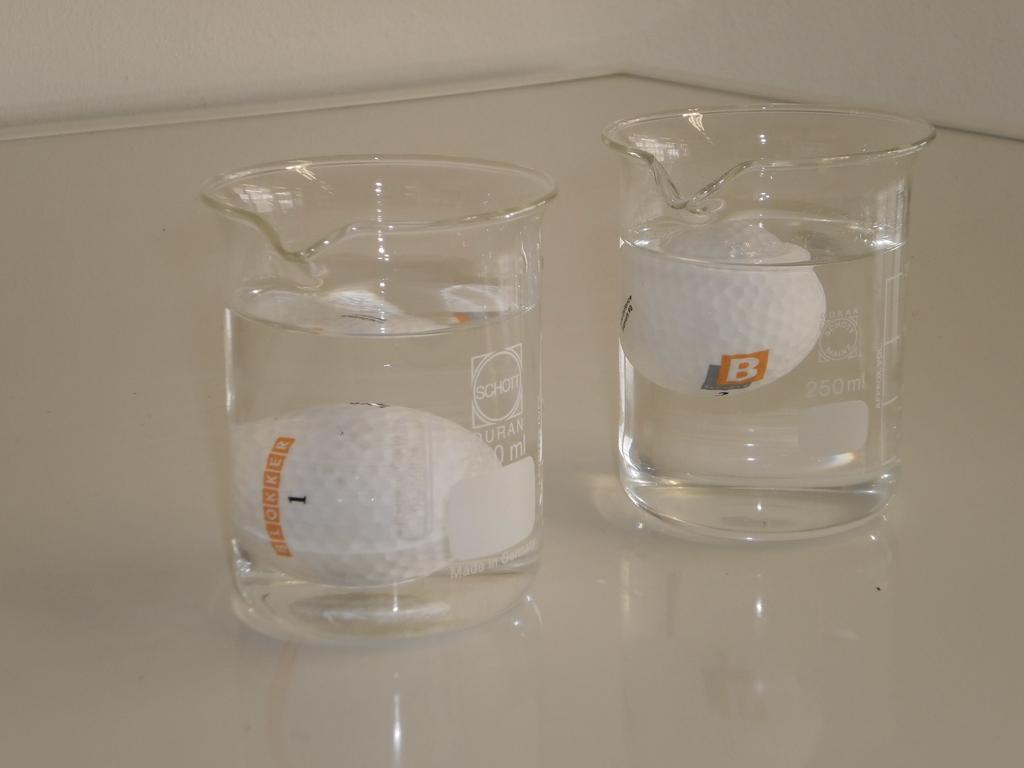<image>
Offer a succinct explanation of the picture presented. Two beakers have one golf ball floating in each of them and one of them says Blokker. 